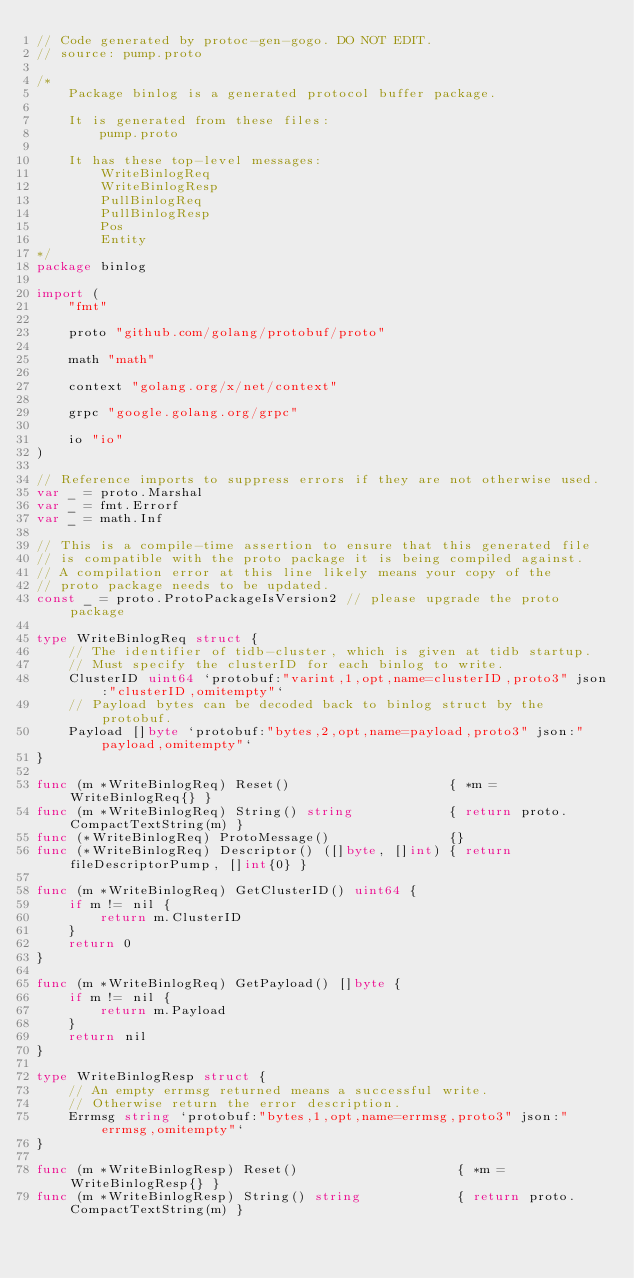<code> <loc_0><loc_0><loc_500><loc_500><_Go_>// Code generated by protoc-gen-gogo. DO NOT EDIT.
// source: pump.proto

/*
	Package binlog is a generated protocol buffer package.

	It is generated from these files:
		pump.proto

	It has these top-level messages:
		WriteBinlogReq
		WriteBinlogResp
		PullBinlogReq
		PullBinlogResp
		Pos
		Entity
*/
package binlog

import (
	"fmt"

	proto "github.com/golang/protobuf/proto"

	math "math"

	context "golang.org/x/net/context"

	grpc "google.golang.org/grpc"

	io "io"
)

// Reference imports to suppress errors if they are not otherwise used.
var _ = proto.Marshal
var _ = fmt.Errorf
var _ = math.Inf

// This is a compile-time assertion to ensure that this generated file
// is compatible with the proto package it is being compiled against.
// A compilation error at this line likely means your copy of the
// proto package needs to be updated.
const _ = proto.ProtoPackageIsVersion2 // please upgrade the proto package

type WriteBinlogReq struct {
	// The identifier of tidb-cluster, which is given at tidb startup.
	// Must specify the clusterID for each binlog to write.
	ClusterID uint64 `protobuf:"varint,1,opt,name=clusterID,proto3" json:"clusterID,omitempty"`
	// Payload bytes can be decoded back to binlog struct by the protobuf.
	Payload []byte `protobuf:"bytes,2,opt,name=payload,proto3" json:"payload,omitempty"`
}

func (m *WriteBinlogReq) Reset()                    { *m = WriteBinlogReq{} }
func (m *WriteBinlogReq) String() string            { return proto.CompactTextString(m) }
func (*WriteBinlogReq) ProtoMessage()               {}
func (*WriteBinlogReq) Descriptor() ([]byte, []int) { return fileDescriptorPump, []int{0} }

func (m *WriteBinlogReq) GetClusterID() uint64 {
	if m != nil {
		return m.ClusterID
	}
	return 0
}

func (m *WriteBinlogReq) GetPayload() []byte {
	if m != nil {
		return m.Payload
	}
	return nil
}

type WriteBinlogResp struct {
	// An empty errmsg returned means a successful write.
	// Otherwise return the error description.
	Errmsg string `protobuf:"bytes,1,opt,name=errmsg,proto3" json:"errmsg,omitempty"`
}

func (m *WriteBinlogResp) Reset()                    { *m = WriteBinlogResp{} }
func (m *WriteBinlogResp) String() string            { return proto.CompactTextString(m) }</code> 